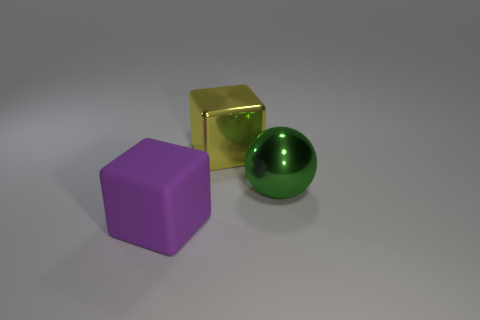How many other big things are the same shape as the rubber thing?
Ensure brevity in your answer.  1. What is the size of the green object that is made of the same material as the large yellow block?
Offer a terse response. Large. Are any big purple shiny things visible?
Offer a terse response. No. There is a thing behind the large object that is right of the cube that is behind the purple thing; how big is it?
Make the answer very short. Large. How many green objects are made of the same material as the yellow object?
Your response must be concise. 1. What number of other green objects have the same size as the green metallic thing?
Your answer should be very brief. 0. What is the material of the big thing behind the large shiny object that is right of the cube to the right of the purple matte thing?
Your answer should be very brief. Metal. What number of things are large matte blocks or big red blocks?
Offer a terse response. 1. Is there any other thing that has the same material as the big purple object?
Your response must be concise. No. What is the shape of the big green thing?
Offer a very short reply. Sphere. 